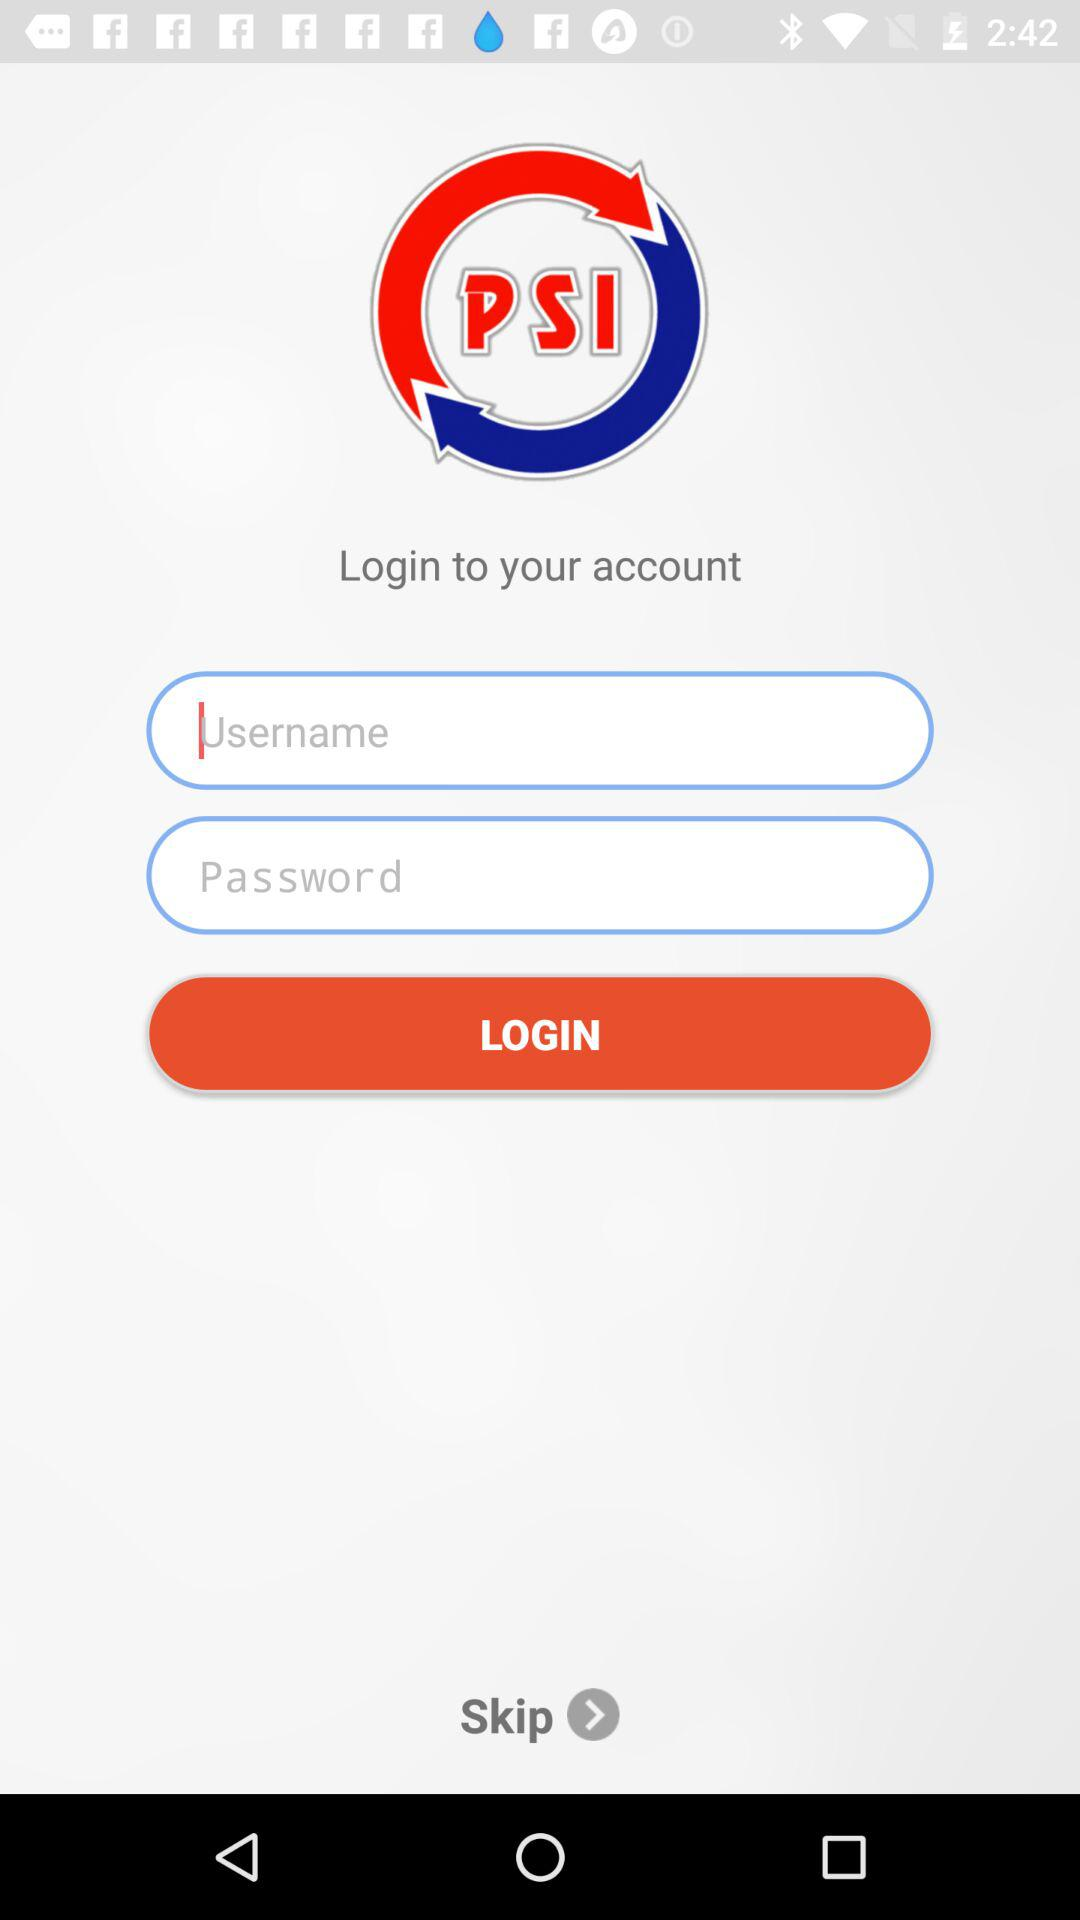How many inputs are there for the user to provide information?
Answer the question using a single word or phrase. 2 